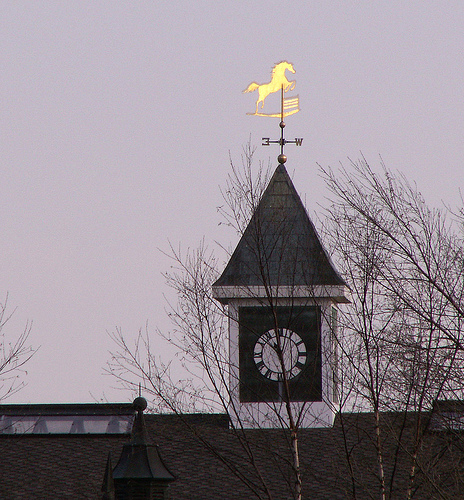<image>
Is there a horse in the sky? Yes. The horse is contained within or inside the sky, showing a containment relationship. 